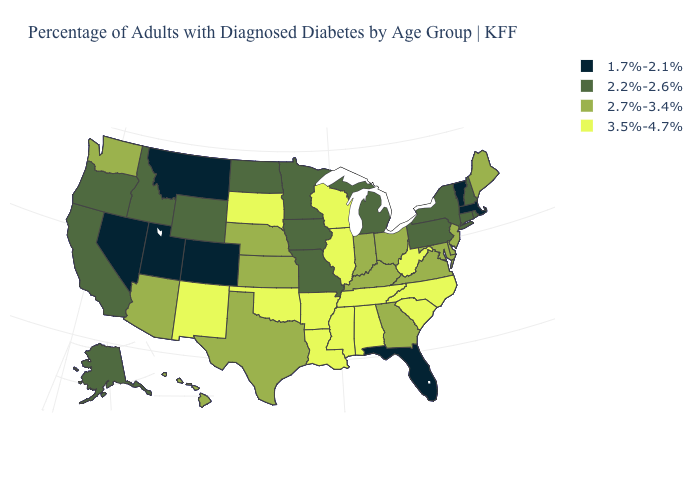What is the highest value in the USA?
Write a very short answer. 3.5%-4.7%. What is the value of Idaho?
Short answer required. 2.2%-2.6%. What is the value of South Carolina?
Write a very short answer. 3.5%-4.7%. What is the highest value in the MidWest ?
Short answer required. 3.5%-4.7%. Name the states that have a value in the range 1.7%-2.1%?
Quick response, please. Colorado, Florida, Massachusetts, Montana, Nevada, Utah, Vermont. What is the value of Wisconsin?
Quick response, please. 3.5%-4.7%. What is the lowest value in the USA?
Answer briefly. 1.7%-2.1%. Name the states that have a value in the range 2.7%-3.4%?
Answer briefly. Arizona, Delaware, Georgia, Hawaii, Indiana, Kansas, Kentucky, Maine, Maryland, Nebraska, New Jersey, Ohio, Texas, Virginia, Washington. Among the states that border West Virginia , which have the highest value?
Give a very brief answer. Kentucky, Maryland, Ohio, Virginia. Which states hav the highest value in the West?
Answer briefly. New Mexico. Among the states that border Rhode Island , which have the lowest value?
Short answer required. Massachusetts. Does Alaska have the same value as Arkansas?
Write a very short answer. No. How many symbols are there in the legend?
Concise answer only. 4. Name the states that have a value in the range 3.5%-4.7%?
Short answer required. Alabama, Arkansas, Illinois, Louisiana, Mississippi, New Mexico, North Carolina, Oklahoma, South Carolina, South Dakota, Tennessee, West Virginia, Wisconsin. Name the states that have a value in the range 2.2%-2.6%?
Quick response, please. Alaska, California, Connecticut, Idaho, Iowa, Michigan, Minnesota, Missouri, New Hampshire, New York, North Dakota, Oregon, Pennsylvania, Rhode Island, Wyoming. 